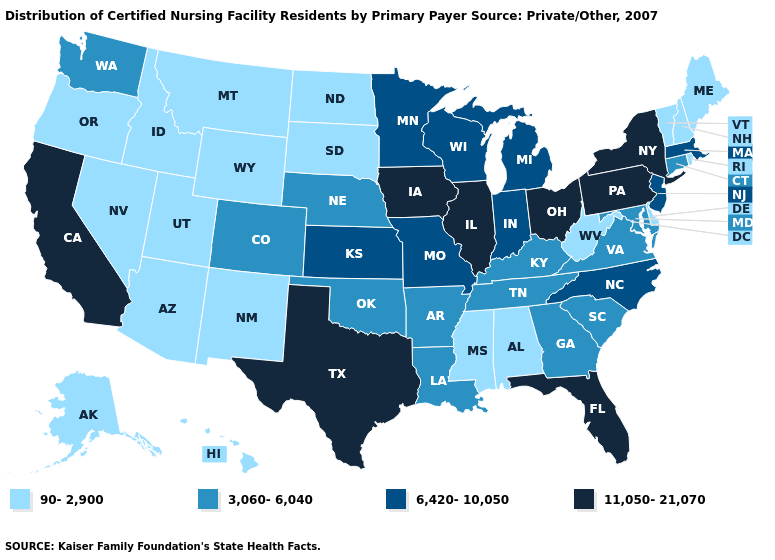Name the states that have a value in the range 90-2,900?
Concise answer only. Alabama, Alaska, Arizona, Delaware, Hawaii, Idaho, Maine, Mississippi, Montana, Nevada, New Hampshire, New Mexico, North Dakota, Oregon, Rhode Island, South Dakota, Utah, Vermont, West Virginia, Wyoming. Name the states that have a value in the range 6,420-10,050?
Give a very brief answer. Indiana, Kansas, Massachusetts, Michigan, Minnesota, Missouri, New Jersey, North Carolina, Wisconsin. Name the states that have a value in the range 3,060-6,040?
Give a very brief answer. Arkansas, Colorado, Connecticut, Georgia, Kentucky, Louisiana, Maryland, Nebraska, Oklahoma, South Carolina, Tennessee, Virginia, Washington. Does Nebraska have a lower value than Missouri?
Be succinct. Yes. Name the states that have a value in the range 6,420-10,050?
Quick response, please. Indiana, Kansas, Massachusetts, Michigan, Minnesota, Missouri, New Jersey, North Carolina, Wisconsin. Name the states that have a value in the range 11,050-21,070?
Give a very brief answer. California, Florida, Illinois, Iowa, New York, Ohio, Pennsylvania, Texas. Does Alaska have the lowest value in the West?
Keep it brief. Yes. Name the states that have a value in the range 11,050-21,070?
Write a very short answer. California, Florida, Illinois, Iowa, New York, Ohio, Pennsylvania, Texas. Does Kansas have the highest value in the MidWest?
Write a very short answer. No. What is the highest value in the USA?
Quick response, please. 11,050-21,070. Which states hav the highest value in the Northeast?
Give a very brief answer. New York, Pennsylvania. What is the highest value in the MidWest ?
Be succinct. 11,050-21,070. Name the states that have a value in the range 6,420-10,050?
Keep it brief. Indiana, Kansas, Massachusetts, Michigan, Minnesota, Missouri, New Jersey, North Carolina, Wisconsin. What is the highest value in states that border Arizona?
Quick response, please. 11,050-21,070. Name the states that have a value in the range 3,060-6,040?
Answer briefly. Arkansas, Colorado, Connecticut, Georgia, Kentucky, Louisiana, Maryland, Nebraska, Oklahoma, South Carolina, Tennessee, Virginia, Washington. 